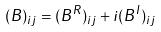<formula> <loc_0><loc_0><loc_500><loc_500>( B ) _ { i j } = ( B ^ { R } ) _ { i j } + i ( B ^ { I } ) _ { i j }</formula> 